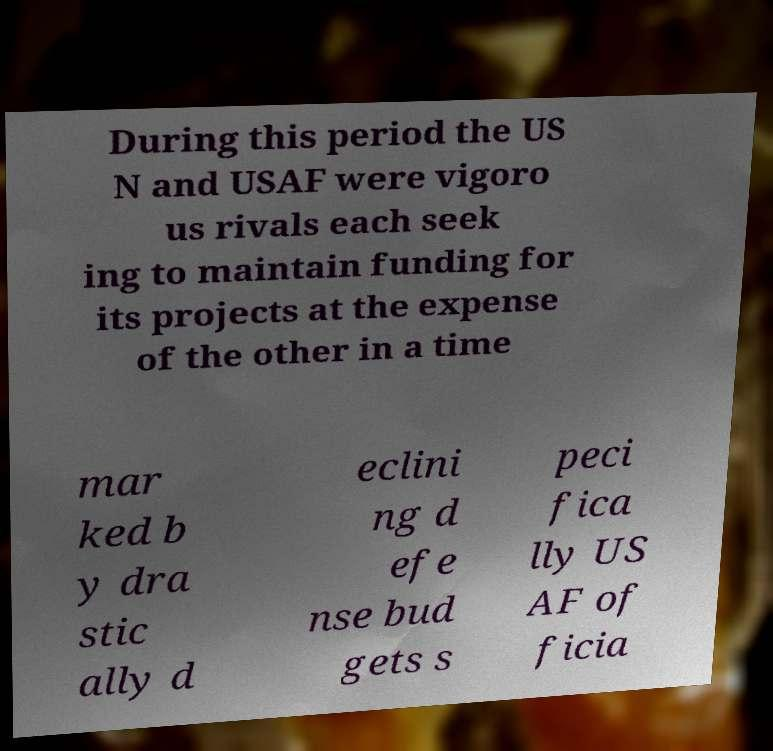I need the written content from this picture converted into text. Can you do that? During this period the US N and USAF were vigoro us rivals each seek ing to maintain funding for its projects at the expense of the other in a time mar ked b y dra stic ally d eclini ng d efe nse bud gets s peci fica lly US AF of ficia 